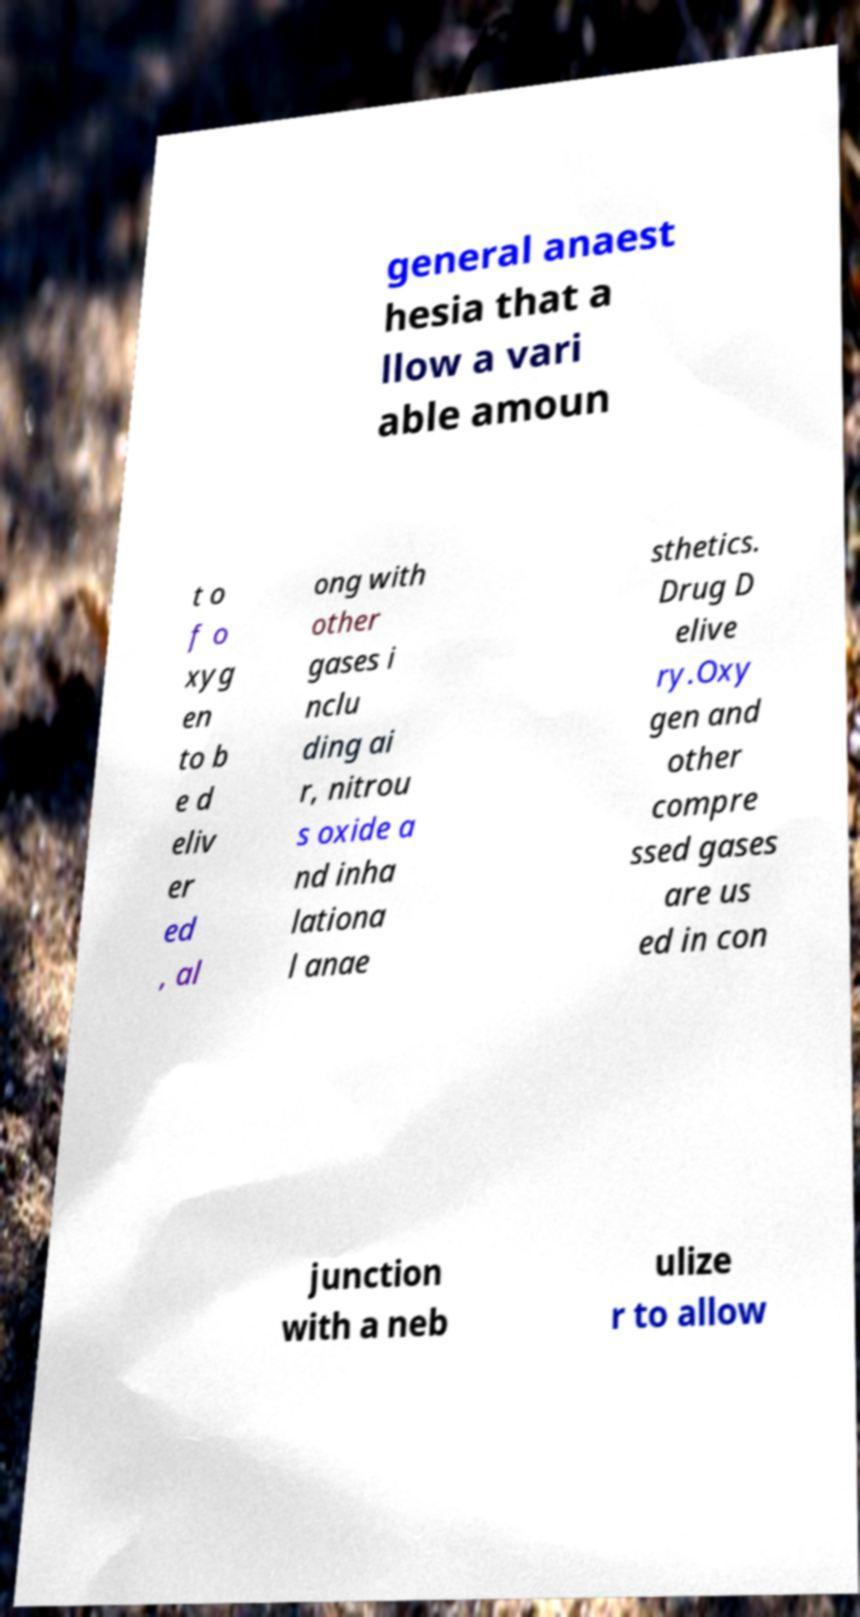What messages or text are displayed in this image? I need them in a readable, typed format. general anaest hesia that a llow a vari able amoun t o f o xyg en to b e d eliv er ed , al ong with other gases i nclu ding ai r, nitrou s oxide a nd inha lationa l anae sthetics. Drug D elive ry.Oxy gen and other compre ssed gases are us ed in con junction with a neb ulize r to allow 